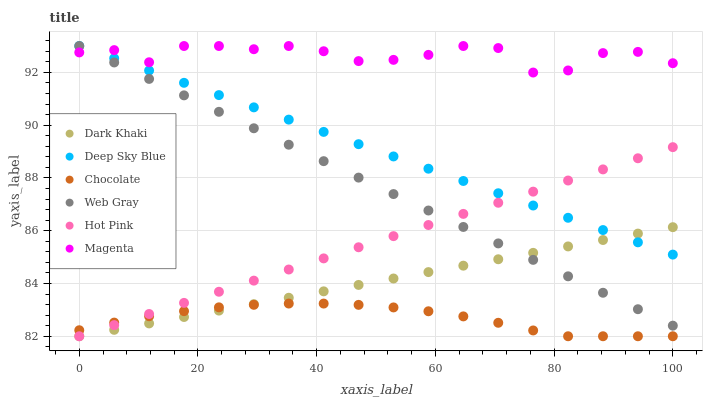Does Chocolate have the minimum area under the curve?
Answer yes or no. Yes. Does Magenta have the maximum area under the curve?
Answer yes or no. Yes. Does Hot Pink have the minimum area under the curve?
Answer yes or no. No. Does Hot Pink have the maximum area under the curve?
Answer yes or no. No. Is Dark Khaki the smoothest?
Answer yes or no. Yes. Is Magenta the roughest?
Answer yes or no. Yes. Is Hot Pink the smoothest?
Answer yes or no. No. Is Hot Pink the roughest?
Answer yes or no. No. Does Hot Pink have the lowest value?
Answer yes or no. Yes. Does Deep Sky Blue have the lowest value?
Answer yes or no. No. Does Magenta have the highest value?
Answer yes or no. Yes. Does Hot Pink have the highest value?
Answer yes or no. No. Is Hot Pink less than Magenta?
Answer yes or no. Yes. Is Magenta greater than Dark Khaki?
Answer yes or no. Yes. Does Deep Sky Blue intersect Dark Khaki?
Answer yes or no. Yes. Is Deep Sky Blue less than Dark Khaki?
Answer yes or no. No. Is Deep Sky Blue greater than Dark Khaki?
Answer yes or no. No. Does Hot Pink intersect Magenta?
Answer yes or no. No. 